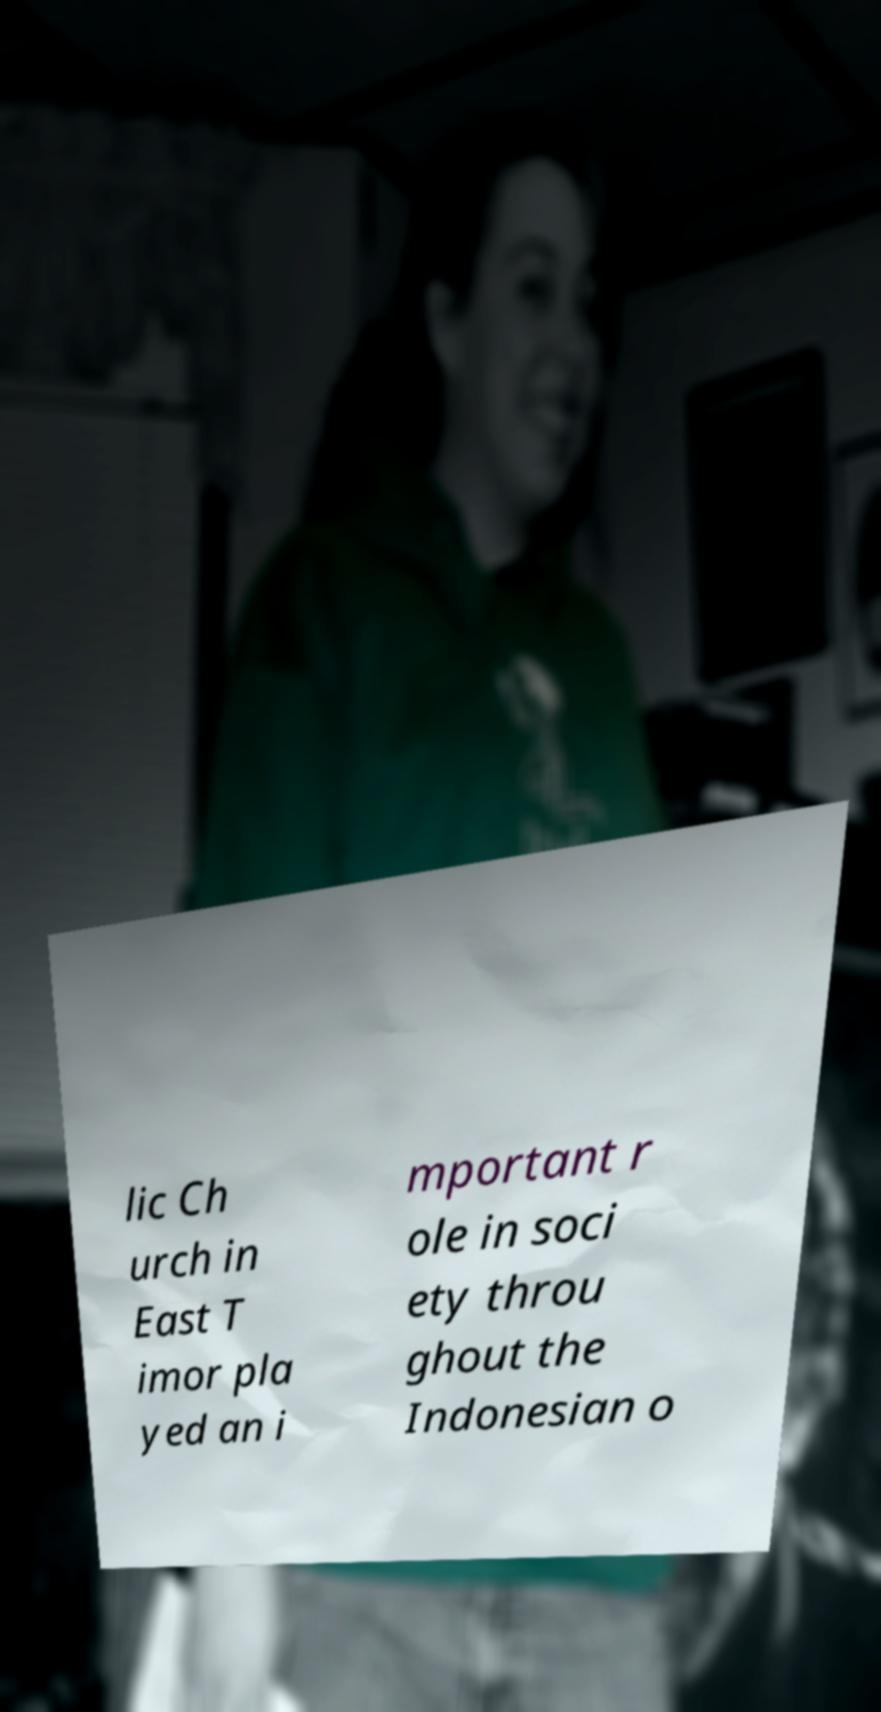For documentation purposes, I need the text within this image transcribed. Could you provide that? lic Ch urch in East T imor pla yed an i mportant r ole in soci ety throu ghout the Indonesian o 